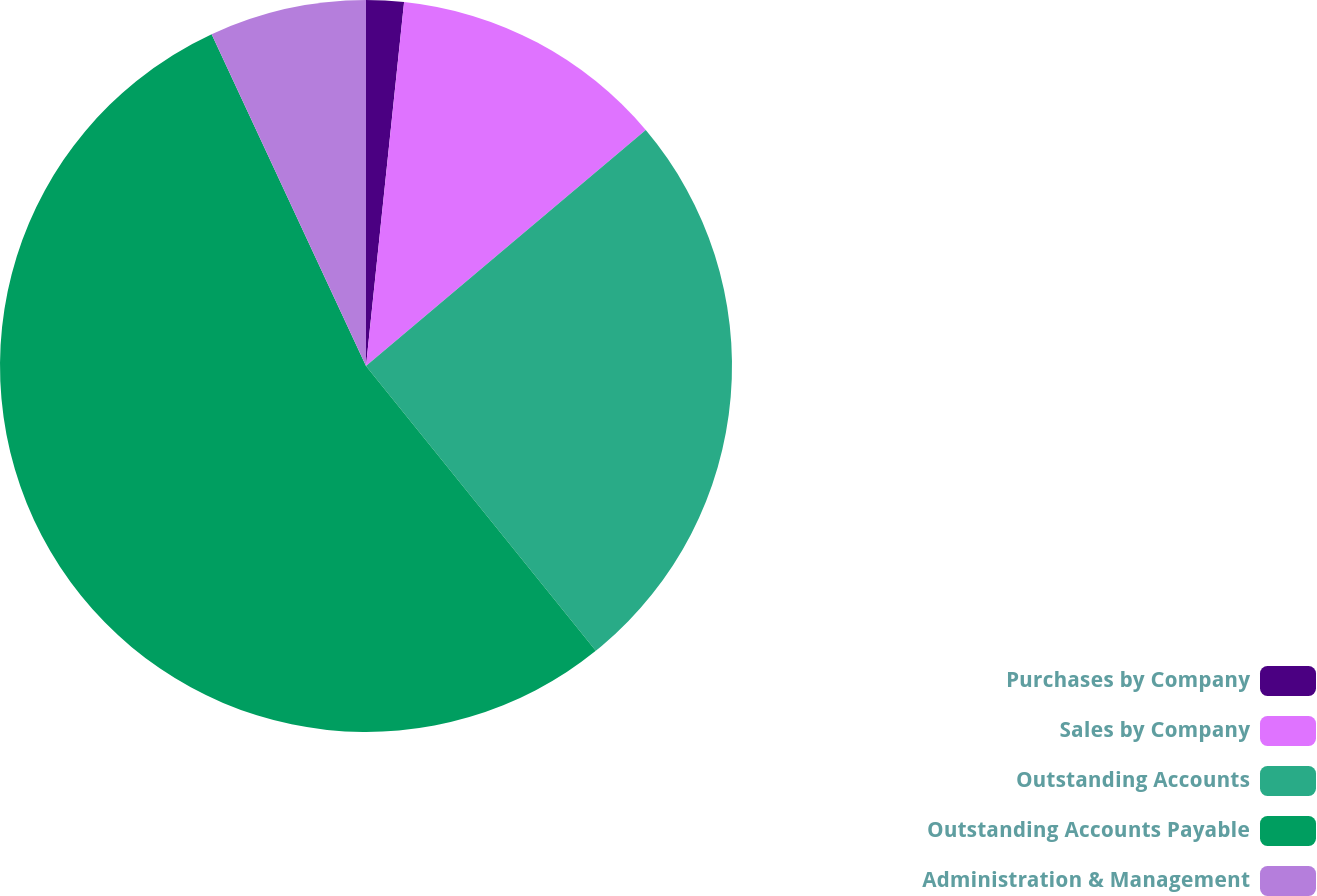Convert chart to OTSL. <chart><loc_0><loc_0><loc_500><loc_500><pie_chart><fcel>Purchases by Company<fcel>Sales by Company<fcel>Outstanding Accounts<fcel>Outstanding Accounts Payable<fcel>Administration & Management<nl><fcel>1.66%<fcel>12.19%<fcel>25.35%<fcel>53.88%<fcel>6.93%<nl></chart> 